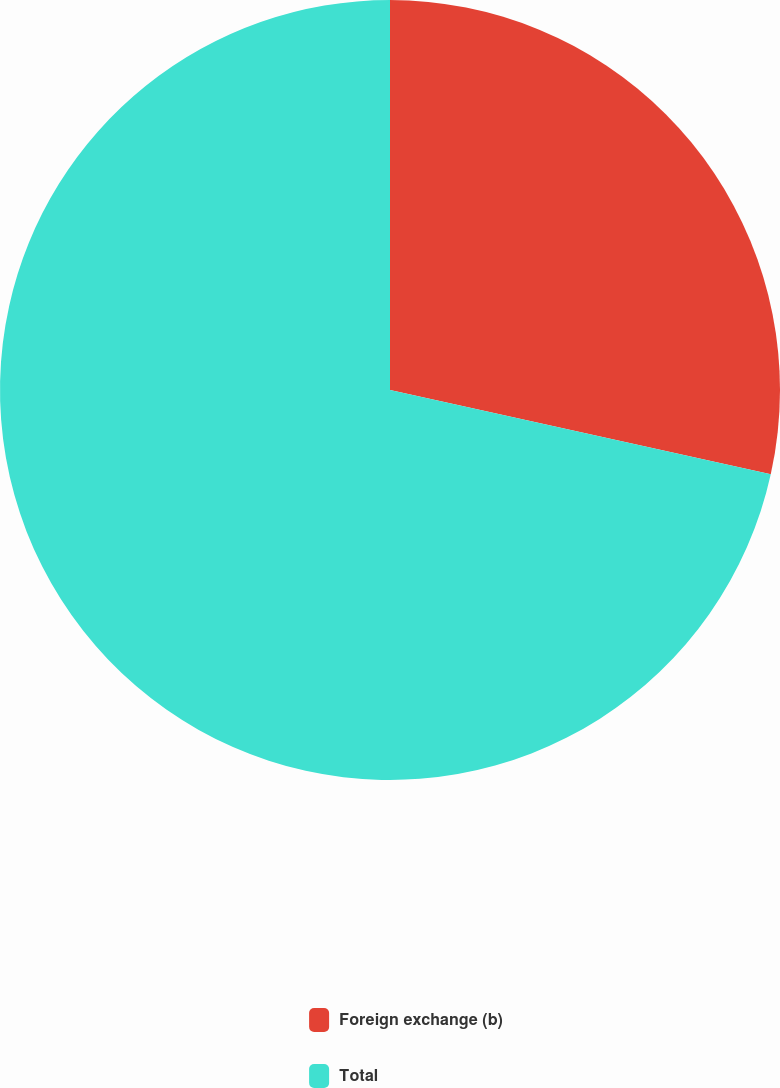Convert chart to OTSL. <chart><loc_0><loc_0><loc_500><loc_500><pie_chart><fcel>Foreign exchange (b)<fcel>Total<nl><fcel>28.47%<fcel>71.53%<nl></chart> 